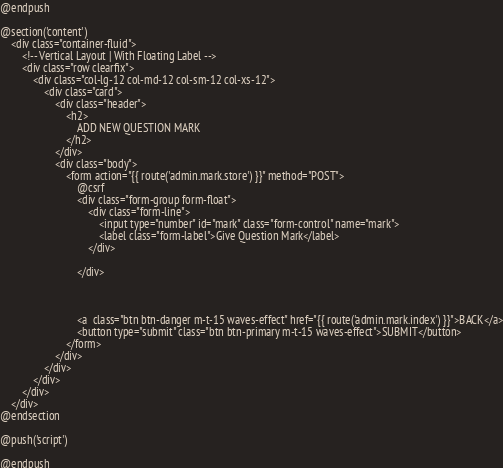Convert code to text. <code><loc_0><loc_0><loc_500><loc_500><_PHP_>
@endpush

@section('content')
    <div class="container-fluid">
        <!-- Vertical Layout | With Floating Label -->
        <div class="row clearfix">
            <div class="col-lg-12 col-md-12 col-sm-12 col-xs-12">
                <div class="card">
                    <div class="header">
                        <h2>
                            ADD NEW QUESTION MARK
                        </h2>
                    </div>
                    <div class="body">
                        <form action="{{ route('admin.mark.store') }}" method="POST">
                            @csrf
                            <div class="form-group form-float">
                                <div class="form-line">
                                    <input type="number" id="mark" class="form-control" name="mark">
                                    <label class="form-label">Give Question Mark</label>
                                </div>

                            </div>



                            <a  class="btn btn-danger m-t-15 waves-effect" href="{{ route('admin.mark.index') }}">BACK</a>
                            <button type="submit" class="btn btn-primary m-t-15 waves-effect">SUBMIT</button>
                        </form>
                    </div>
                </div>
            </div>
        </div>
    </div>
@endsection

@push('script')

@endpush</code> 